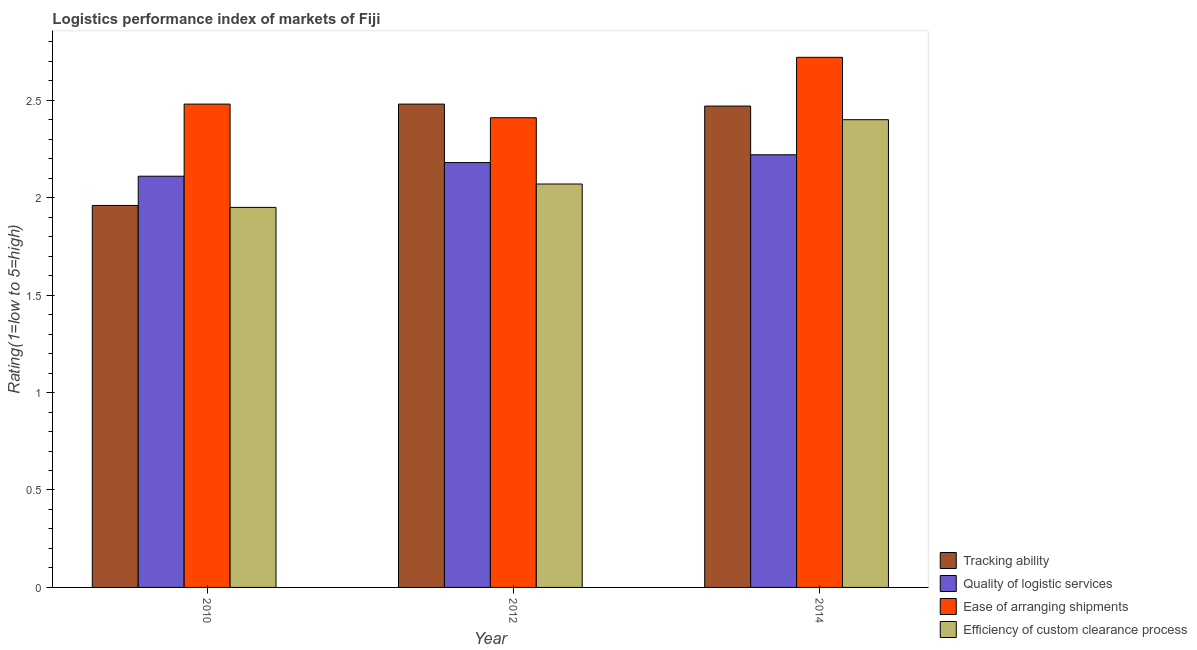How many groups of bars are there?
Provide a succinct answer. 3. Are the number of bars on each tick of the X-axis equal?
Keep it short and to the point. Yes. How many bars are there on the 1st tick from the right?
Offer a terse response. 4. What is the lpi rating of efficiency of custom clearance process in 2012?
Ensure brevity in your answer.  2.07. Across all years, what is the maximum lpi rating of efficiency of custom clearance process?
Offer a very short reply. 2.4. Across all years, what is the minimum lpi rating of quality of logistic services?
Ensure brevity in your answer.  2.11. In which year was the lpi rating of quality of logistic services maximum?
Make the answer very short. 2014. What is the total lpi rating of tracking ability in the graph?
Make the answer very short. 6.91. What is the difference between the lpi rating of efficiency of custom clearance process in 2010 and that in 2014?
Make the answer very short. -0.45. What is the difference between the lpi rating of quality of logistic services in 2014 and the lpi rating of efficiency of custom clearance process in 2012?
Your response must be concise. 0.04. What is the average lpi rating of quality of logistic services per year?
Your answer should be very brief. 2.17. In the year 2014, what is the difference between the lpi rating of tracking ability and lpi rating of ease of arranging shipments?
Offer a very short reply. 0. What is the ratio of the lpi rating of quality of logistic services in 2012 to that in 2014?
Give a very brief answer. 0.98. What is the difference between the highest and the second highest lpi rating of quality of logistic services?
Keep it short and to the point. 0.04. What is the difference between the highest and the lowest lpi rating of ease of arranging shipments?
Make the answer very short. 0.31. In how many years, is the lpi rating of ease of arranging shipments greater than the average lpi rating of ease of arranging shipments taken over all years?
Make the answer very short. 1. Is the sum of the lpi rating of tracking ability in 2010 and 2012 greater than the maximum lpi rating of ease of arranging shipments across all years?
Keep it short and to the point. Yes. Is it the case that in every year, the sum of the lpi rating of efficiency of custom clearance process and lpi rating of tracking ability is greater than the sum of lpi rating of quality of logistic services and lpi rating of ease of arranging shipments?
Provide a short and direct response. No. What does the 2nd bar from the left in 2012 represents?
Your answer should be very brief. Quality of logistic services. What does the 4th bar from the right in 2014 represents?
Offer a very short reply. Tracking ability. Is it the case that in every year, the sum of the lpi rating of tracking ability and lpi rating of quality of logistic services is greater than the lpi rating of ease of arranging shipments?
Provide a succinct answer. Yes. How many bars are there?
Your answer should be very brief. 12. How many years are there in the graph?
Your response must be concise. 3. Are the values on the major ticks of Y-axis written in scientific E-notation?
Make the answer very short. No. Does the graph contain grids?
Keep it short and to the point. No. How are the legend labels stacked?
Your response must be concise. Vertical. What is the title of the graph?
Keep it short and to the point. Logistics performance index of markets of Fiji. Does "Quality Certification" appear as one of the legend labels in the graph?
Your response must be concise. No. What is the label or title of the Y-axis?
Give a very brief answer. Rating(1=low to 5=high). What is the Rating(1=low to 5=high) in Tracking ability in 2010?
Make the answer very short. 1.96. What is the Rating(1=low to 5=high) of Quality of logistic services in 2010?
Make the answer very short. 2.11. What is the Rating(1=low to 5=high) in Ease of arranging shipments in 2010?
Offer a terse response. 2.48. What is the Rating(1=low to 5=high) of Efficiency of custom clearance process in 2010?
Your answer should be very brief. 1.95. What is the Rating(1=low to 5=high) in Tracking ability in 2012?
Offer a very short reply. 2.48. What is the Rating(1=low to 5=high) in Quality of logistic services in 2012?
Give a very brief answer. 2.18. What is the Rating(1=low to 5=high) of Ease of arranging shipments in 2012?
Make the answer very short. 2.41. What is the Rating(1=low to 5=high) in Efficiency of custom clearance process in 2012?
Make the answer very short. 2.07. What is the Rating(1=low to 5=high) of Tracking ability in 2014?
Your answer should be compact. 2.47. What is the Rating(1=low to 5=high) of Quality of logistic services in 2014?
Provide a short and direct response. 2.22. What is the Rating(1=low to 5=high) of Ease of arranging shipments in 2014?
Your answer should be very brief. 2.72. What is the Rating(1=low to 5=high) in Efficiency of custom clearance process in 2014?
Give a very brief answer. 2.4. Across all years, what is the maximum Rating(1=low to 5=high) in Tracking ability?
Offer a terse response. 2.48. Across all years, what is the maximum Rating(1=low to 5=high) of Quality of logistic services?
Ensure brevity in your answer.  2.22. Across all years, what is the maximum Rating(1=low to 5=high) in Ease of arranging shipments?
Provide a short and direct response. 2.72. Across all years, what is the minimum Rating(1=low to 5=high) in Tracking ability?
Offer a terse response. 1.96. Across all years, what is the minimum Rating(1=low to 5=high) in Quality of logistic services?
Provide a short and direct response. 2.11. Across all years, what is the minimum Rating(1=low to 5=high) in Ease of arranging shipments?
Your response must be concise. 2.41. Across all years, what is the minimum Rating(1=low to 5=high) in Efficiency of custom clearance process?
Make the answer very short. 1.95. What is the total Rating(1=low to 5=high) in Tracking ability in the graph?
Your answer should be very brief. 6.91. What is the total Rating(1=low to 5=high) in Quality of logistic services in the graph?
Offer a very short reply. 6.51. What is the total Rating(1=low to 5=high) in Ease of arranging shipments in the graph?
Ensure brevity in your answer.  7.61. What is the total Rating(1=low to 5=high) of Efficiency of custom clearance process in the graph?
Offer a terse response. 6.42. What is the difference between the Rating(1=low to 5=high) of Tracking ability in 2010 and that in 2012?
Your response must be concise. -0.52. What is the difference between the Rating(1=low to 5=high) in Quality of logistic services in 2010 and that in 2012?
Offer a very short reply. -0.07. What is the difference between the Rating(1=low to 5=high) of Ease of arranging shipments in 2010 and that in 2012?
Keep it short and to the point. 0.07. What is the difference between the Rating(1=low to 5=high) of Efficiency of custom clearance process in 2010 and that in 2012?
Provide a short and direct response. -0.12. What is the difference between the Rating(1=low to 5=high) of Tracking ability in 2010 and that in 2014?
Your answer should be very brief. -0.51. What is the difference between the Rating(1=low to 5=high) in Quality of logistic services in 2010 and that in 2014?
Keep it short and to the point. -0.11. What is the difference between the Rating(1=low to 5=high) of Ease of arranging shipments in 2010 and that in 2014?
Give a very brief answer. -0.24. What is the difference between the Rating(1=low to 5=high) in Efficiency of custom clearance process in 2010 and that in 2014?
Your response must be concise. -0.45. What is the difference between the Rating(1=low to 5=high) of Tracking ability in 2012 and that in 2014?
Make the answer very short. 0.01. What is the difference between the Rating(1=low to 5=high) in Quality of logistic services in 2012 and that in 2014?
Your answer should be compact. -0.04. What is the difference between the Rating(1=low to 5=high) of Ease of arranging shipments in 2012 and that in 2014?
Offer a terse response. -0.31. What is the difference between the Rating(1=low to 5=high) in Efficiency of custom clearance process in 2012 and that in 2014?
Provide a short and direct response. -0.33. What is the difference between the Rating(1=low to 5=high) of Tracking ability in 2010 and the Rating(1=low to 5=high) of Quality of logistic services in 2012?
Provide a short and direct response. -0.22. What is the difference between the Rating(1=low to 5=high) in Tracking ability in 2010 and the Rating(1=low to 5=high) in Ease of arranging shipments in 2012?
Your answer should be very brief. -0.45. What is the difference between the Rating(1=low to 5=high) of Tracking ability in 2010 and the Rating(1=low to 5=high) of Efficiency of custom clearance process in 2012?
Make the answer very short. -0.11. What is the difference between the Rating(1=low to 5=high) of Quality of logistic services in 2010 and the Rating(1=low to 5=high) of Ease of arranging shipments in 2012?
Your response must be concise. -0.3. What is the difference between the Rating(1=low to 5=high) of Quality of logistic services in 2010 and the Rating(1=low to 5=high) of Efficiency of custom clearance process in 2012?
Your answer should be compact. 0.04. What is the difference between the Rating(1=low to 5=high) of Ease of arranging shipments in 2010 and the Rating(1=low to 5=high) of Efficiency of custom clearance process in 2012?
Your answer should be very brief. 0.41. What is the difference between the Rating(1=low to 5=high) in Tracking ability in 2010 and the Rating(1=low to 5=high) in Quality of logistic services in 2014?
Give a very brief answer. -0.26. What is the difference between the Rating(1=low to 5=high) of Tracking ability in 2010 and the Rating(1=low to 5=high) of Ease of arranging shipments in 2014?
Your answer should be compact. -0.76. What is the difference between the Rating(1=low to 5=high) of Tracking ability in 2010 and the Rating(1=low to 5=high) of Efficiency of custom clearance process in 2014?
Keep it short and to the point. -0.44. What is the difference between the Rating(1=low to 5=high) of Quality of logistic services in 2010 and the Rating(1=low to 5=high) of Ease of arranging shipments in 2014?
Your response must be concise. -0.61. What is the difference between the Rating(1=low to 5=high) of Quality of logistic services in 2010 and the Rating(1=low to 5=high) of Efficiency of custom clearance process in 2014?
Your response must be concise. -0.29. What is the difference between the Rating(1=low to 5=high) of Tracking ability in 2012 and the Rating(1=low to 5=high) of Quality of logistic services in 2014?
Your answer should be very brief. 0.26. What is the difference between the Rating(1=low to 5=high) in Tracking ability in 2012 and the Rating(1=low to 5=high) in Ease of arranging shipments in 2014?
Your answer should be very brief. -0.24. What is the difference between the Rating(1=low to 5=high) in Tracking ability in 2012 and the Rating(1=low to 5=high) in Efficiency of custom clearance process in 2014?
Your answer should be compact. 0.08. What is the difference between the Rating(1=low to 5=high) of Quality of logistic services in 2012 and the Rating(1=low to 5=high) of Ease of arranging shipments in 2014?
Ensure brevity in your answer.  -0.54. What is the difference between the Rating(1=low to 5=high) of Quality of logistic services in 2012 and the Rating(1=low to 5=high) of Efficiency of custom clearance process in 2014?
Provide a succinct answer. -0.22. What is the difference between the Rating(1=low to 5=high) of Ease of arranging shipments in 2012 and the Rating(1=low to 5=high) of Efficiency of custom clearance process in 2014?
Give a very brief answer. 0.01. What is the average Rating(1=low to 5=high) of Tracking ability per year?
Offer a very short reply. 2.3. What is the average Rating(1=low to 5=high) of Quality of logistic services per year?
Provide a succinct answer. 2.17. What is the average Rating(1=low to 5=high) of Ease of arranging shipments per year?
Provide a short and direct response. 2.54. What is the average Rating(1=low to 5=high) in Efficiency of custom clearance process per year?
Give a very brief answer. 2.14. In the year 2010, what is the difference between the Rating(1=low to 5=high) of Tracking ability and Rating(1=low to 5=high) of Ease of arranging shipments?
Offer a terse response. -0.52. In the year 2010, what is the difference between the Rating(1=low to 5=high) of Quality of logistic services and Rating(1=low to 5=high) of Ease of arranging shipments?
Give a very brief answer. -0.37. In the year 2010, what is the difference between the Rating(1=low to 5=high) in Quality of logistic services and Rating(1=low to 5=high) in Efficiency of custom clearance process?
Ensure brevity in your answer.  0.16. In the year 2010, what is the difference between the Rating(1=low to 5=high) of Ease of arranging shipments and Rating(1=low to 5=high) of Efficiency of custom clearance process?
Provide a short and direct response. 0.53. In the year 2012, what is the difference between the Rating(1=low to 5=high) of Tracking ability and Rating(1=low to 5=high) of Quality of logistic services?
Make the answer very short. 0.3. In the year 2012, what is the difference between the Rating(1=low to 5=high) of Tracking ability and Rating(1=low to 5=high) of Ease of arranging shipments?
Your response must be concise. 0.07. In the year 2012, what is the difference between the Rating(1=low to 5=high) in Tracking ability and Rating(1=low to 5=high) in Efficiency of custom clearance process?
Your answer should be compact. 0.41. In the year 2012, what is the difference between the Rating(1=low to 5=high) in Quality of logistic services and Rating(1=low to 5=high) in Ease of arranging shipments?
Make the answer very short. -0.23. In the year 2012, what is the difference between the Rating(1=low to 5=high) in Quality of logistic services and Rating(1=low to 5=high) in Efficiency of custom clearance process?
Give a very brief answer. 0.11. In the year 2012, what is the difference between the Rating(1=low to 5=high) of Ease of arranging shipments and Rating(1=low to 5=high) of Efficiency of custom clearance process?
Ensure brevity in your answer.  0.34. In the year 2014, what is the difference between the Rating(1=low to 5=high) of Tracking ability and Rating(1=low to 5=high) of Quality of logistic services?
Offer a very short reply. 0.25. In the year 2014, what is the difference between the Rating(1=low to 5=high) of Tracking ability and Rating(1=low to 5=high) of Ease of arranging shipments?
Ensure brevity in your answer.  -0.25. In the year 2014, what is the difference between the Rating(1=low to 5=high) of Tracking ability and Rating(1=low to 5=high) of Efficiency of custom clearance process?
Offer a terse response. 0.07. In the year 2014, what is the difference between the Rating(1=low to 5=high) of Quality of logistic services and Rating(1=low to 5=high) of Efficiency of custom clearance process?
Your answer should be very brief. -0.18. In the year 2014, what is the difference between the Rating(1=low to 5=high) of Ease of arranging shipments and Rating(1=low to 5=high) of Efficiency of custom clearance process?
Your answer should be compact. 0.32. What is the ratio of the Rating(1=low to 5=high) of Tracking ability in 2010 to that in 2012?
Ensure brevity in your answer.  0.79. What is the ratio of the Rating(1=low to 5=high) of Quality of logistic services in 2010 to that in 2012?
Provide a short and direct response. 0.97. What is the ratio of the Rating(1=low to 5=high) in Efficiency of custom clearance process in 2010 to that in 2012?
Keep it short and to the point. 0.94. What is the ratio of the Rating(1=low to 5=high) of Tracking ability in 2010 to that in 2014?
Your response must be concise. 0.79. What is the ratio of the Rating(1=low to 5=high) in Quality of logistic services in 2010 to that in 2014?
Give a very brief answer. 0.95. What is the ratio of the Rating(1=low to 5=high) of Ease of arranging shipments in 2010 to that in 2014?
Make the answer very short. 0.91. What is the ratio of the Rating(1=low to 5=high) in Efficiency of custom clearance process in 2010 to that in 2014?
Ensure brevity in your answer.  0.81. What is the ratio of the Rating(1=low to 5=high) of Ease of arranging shipments in 2012 to that in 2014?
Your response must be concise. 0.89. What is the ratio of the Rating(1=low to 5=high) of Efficiency of custom clearance process in 2012 to that in 2014?
Keep it short and to the point. 0.86. What is the difference between the highest and the second highest Rating(1=low to 5=high) in Ease of arranging shipments?
Your response must be concise. 0.24. What is the difference between the highest and the second highest Rating(1=low to 5=high) in Efficiency of custom clearance process?
Your response must be concise. 0.33. What is the difference between the highest and the lowest Rating(1=low to 5=high) in Tracking ability?
Give a very brief answer. 0.52. What is the difference between the highest and the lowest Rating(1=low to 5=high) of Quality of logistic services?
Keep it short and to the point. 0.11. What is the difference between the highest and the lowest Rating(1=low to 5=high) in Ease of arranging shipments?
Keep it short and to the point. 0.31. What is the difference between the highest and the lowest Rating(1=low to 5=high) of Efficiency of custom clearance process?
Keep it short and to the point. 0.45. 